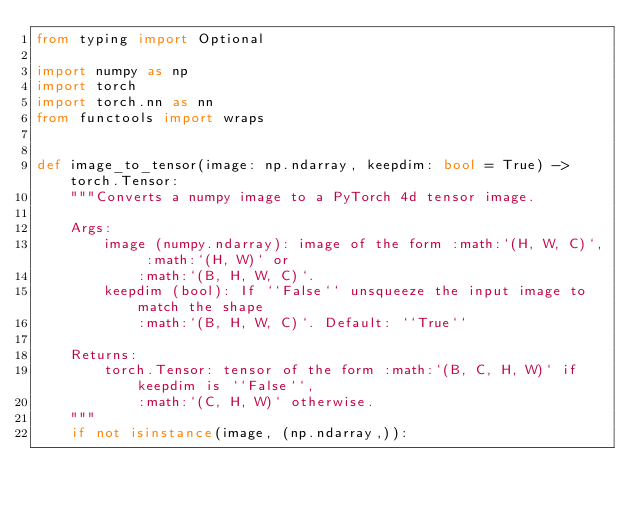<code> <loc_0><loc_0><loc_500><loc_500><_Python_>from typing import Optional

import numpy as np
import torch
import torch.nn as nn
from functools import wraps


def image_to_tensor(image: np.ndarray, keepdim: bool = True) -> torch.Tensor:
    """Converts a numpy image to a PyTorch 4d tensor image.

    Args:
        image (numpy.ndarray): image of the form :math:`(H, W, C)`, :math:`(H, W)` or
            :math:`(B, H, W, C)`.
        keepdim (bool): If ``False`` unsqueeze the input image to match the shape
            :math:`(B, H, W, C)`. Default: ``True``

    Returns:
        torch.Tensor: tensor of the form :math:`(B, C, H, W)` if keepdim is ``False``,
            :math:`(C, H, W)` otherwise.
    """
    if not isinstance(image, (np.ndarray,)):</code> 